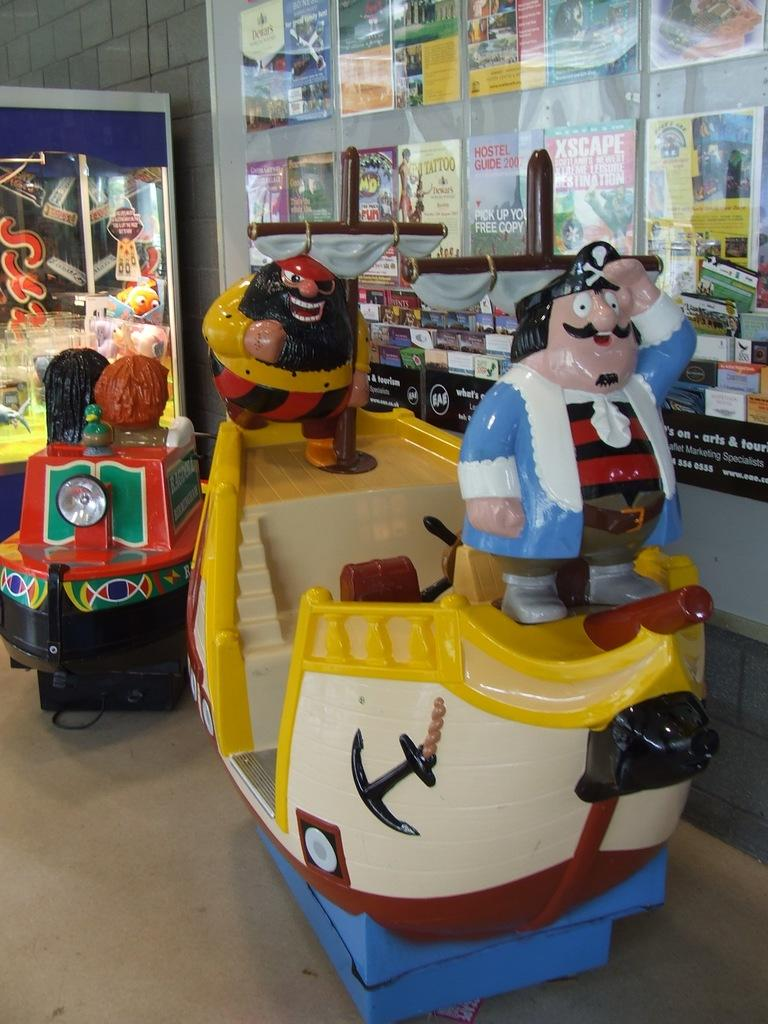<image>
Summarize the visual content of the image. A magazine called Xscape hangs on the wall with some other magazines. 